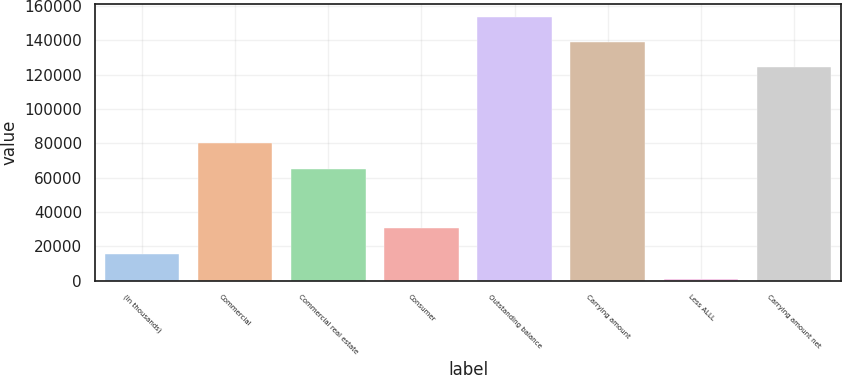<chart> <loc_0><loc_0><loc_500><loc_500><bar_chart><fcel>(In thousands)<fcel>Commercial<fcel>Commercial real estate<fcel>Consumer<fcel>Outstanding balance<fcel>Carrying amount<fcel>Less ALLL<fcel>Carrying amount net<nl><fcel>15719.4<fcel>79941.4<fcel>65167<fcel>30493.8<fcel>153633<fcel>138858<fcel>945<fcel>124084<nl></chart> 